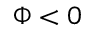Convert formula to latex. <formula><loc_0><loc_0><loc_500><loc_500>\Phi < 0</formula> 